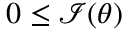<formula> <loc_0><loc_0><loc_500><loc_500>0 \leq { \mathcal { I } } ( \theta )</formula> 